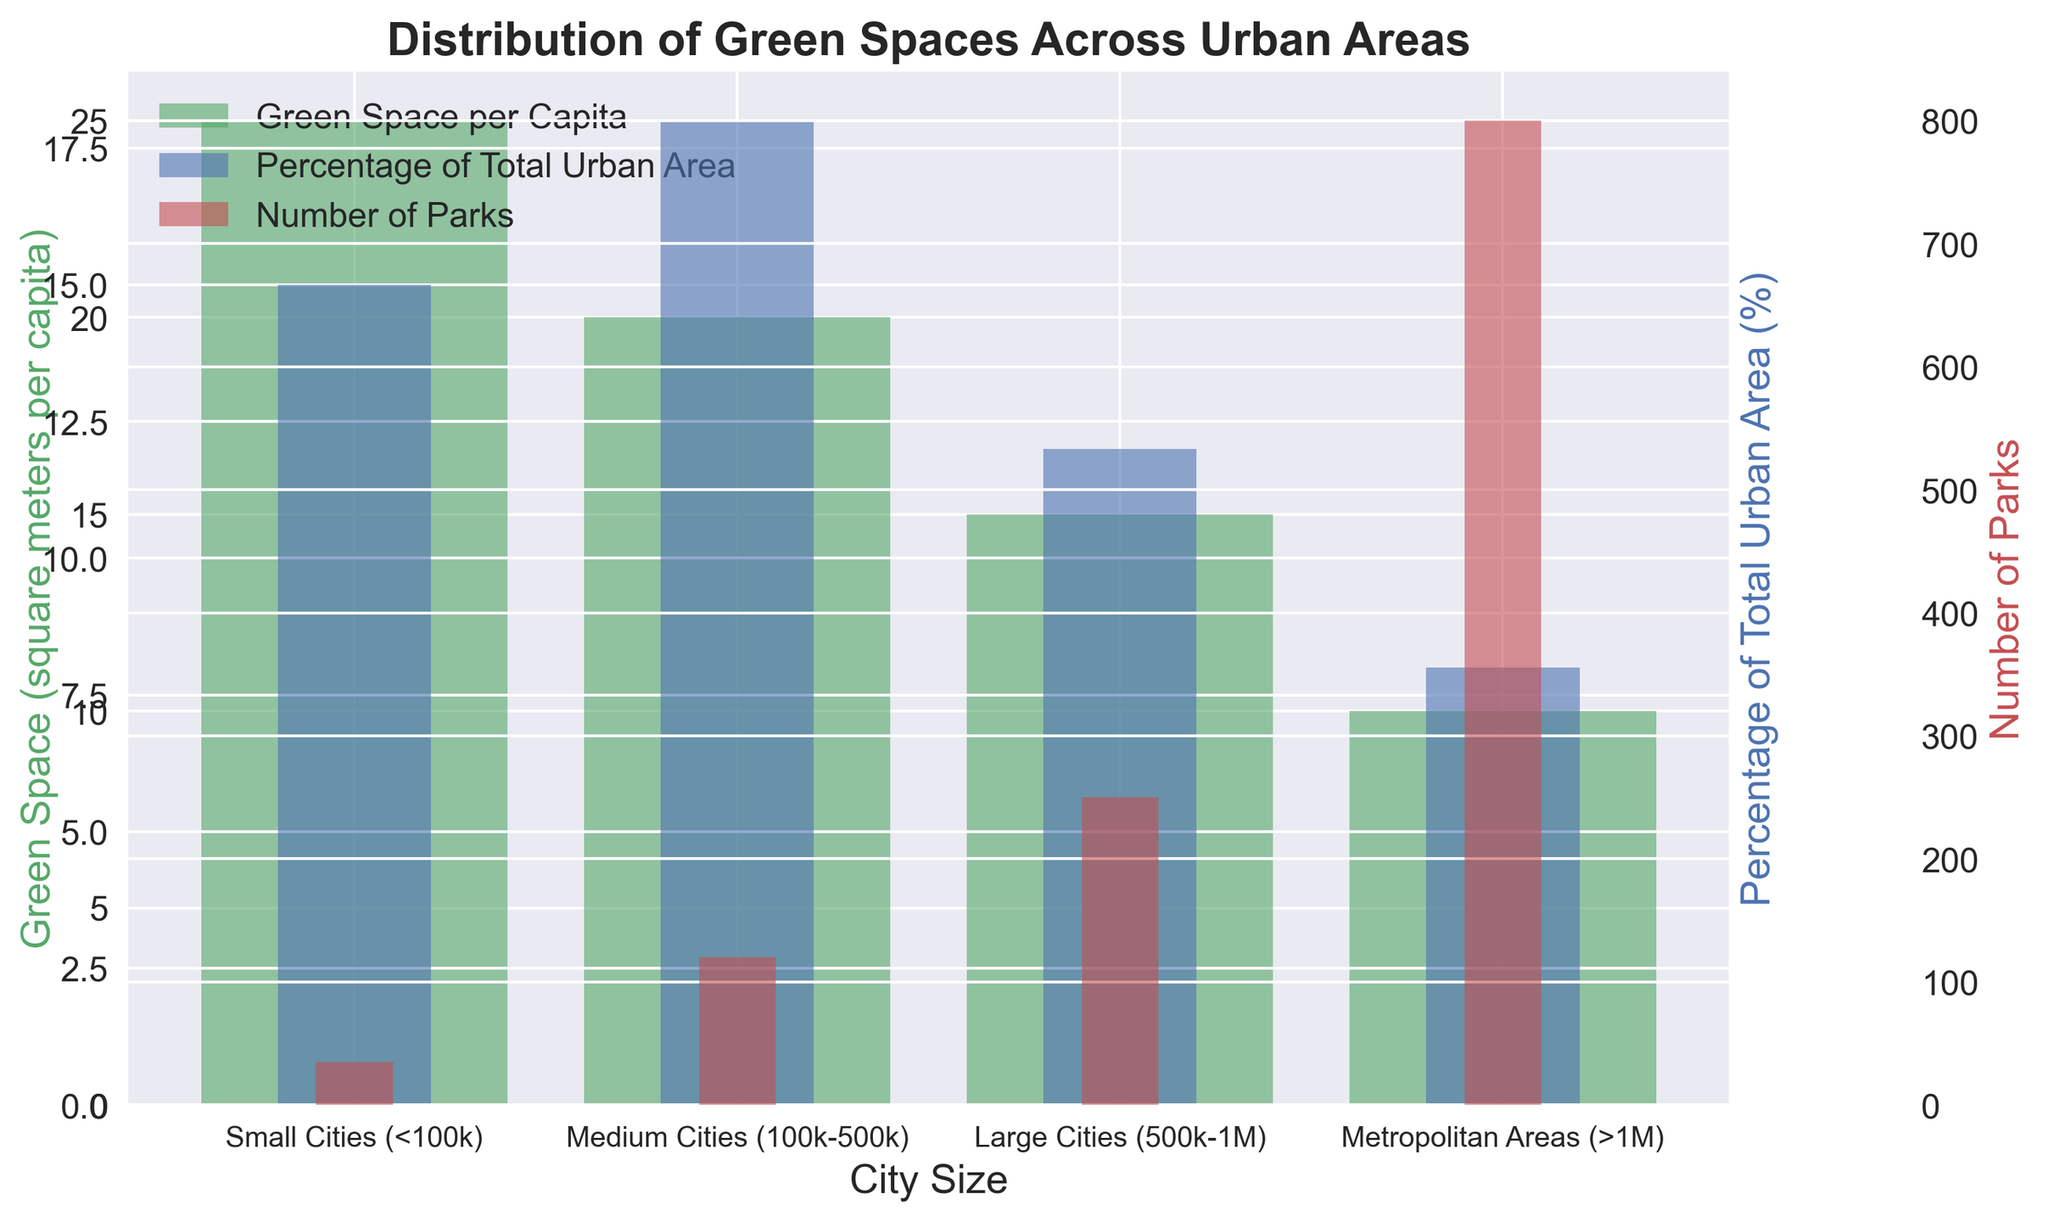What is the green space per capita in medium cities and how does it compare to small cities? The green space per capita in medium cities is 20 square meters, and in small cities, it is 25 square meters. To compare, subtract the green space per capita in medium cities from that in small cities: 25 - 20 = 5 square meters.
Answer: Small cities have 5 square meters more green space per capita Which city size category has the greatest percentage of its urban area as green space? Observing the bar heights for percentage of total urban area, small cities have the highest bar at 15%.
Answer: Small cities Identify the trend in the number of parks as the city size increases from small cities to metropolitan areas. The number of parks increases as the city size grows: small cities have 35 parks, medium cities have 120, large cities have 250, and metropolitan areas have 800 parks.
Answer: Increasing trend How does the percentage of total urban area designated as green space in large cities compare to that in metropolitan areas? Large cities have a bar representing 12%, and metropolitan areas have a bar representing 8%. Metropolitan areas have 4% less green space as a percentage of total urban area: 12% - 8% = 4%.
Answer: Metropolitan areas have 4% less Which category shows the biggest difference between green space per capita and the percentage of total urban area as green space? The difference can be calculated for each category:
- Small Cities: 25 (green space) - 15 (urban area %) = 10
- Medium Cities: 20 - 18 = 2
- Large Cities: 15 - 12 = 3
- Metropolitan Areas: 10 - 8 = 2
The largest difference is for Small Cities (10).
Answer: Small cities Which city size has the smallest amount of green space per capita and what is the value? The lowest bar among city sizes for green space per capita is for metropolitan areas at 10 square meters per capita.
Answer: Metropolitan areas, 10 square meters How do the numbers of parks in small cities and medium cities together compare to the number of parks in metropolitan areas? Small cities have 35 parks and medium cities have 120 parks. Adding these together: 35 + 120 = 155, which is significantly less than the 800 parks in metropolitan areas.
Answer: 155 parks (much less than 800 parks) What is the average percentage of total urban area designated as green space for all city sizes? Sum the percentages for all city sizes and divide by the number of categories: (15+18+12+8)/4 = 53/4 = 13.25%.
Answer: 13.25% How does the green space per capita trend as city size increases? The green space per capita decreases as the city size increases: small cities have 25, medium cities have 20, large cities have 15, and metropolitan areas have 10 square meters per capita.
Answer: Decreasing trend 